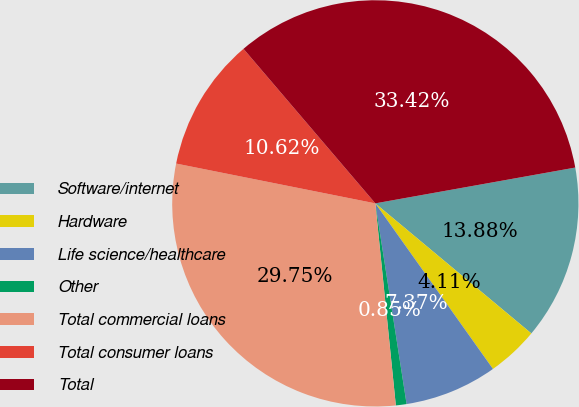<chart> <loc_0><loc_0><loc_500><loc_500><pie_chart><fcel>Software/internet<fcel>Hardware<fcel>Life science/healthcare<fcel>Other<fcel>Total commercial loans<fcel>Total consumer loans<fcel>Total<nl><fcel>13.88%<fcel>4.11%<fcel>7.37%<fcel>0.85%<fcel>29.75%<fcel>10.62%<fcel>33.42%<nl></chart> 